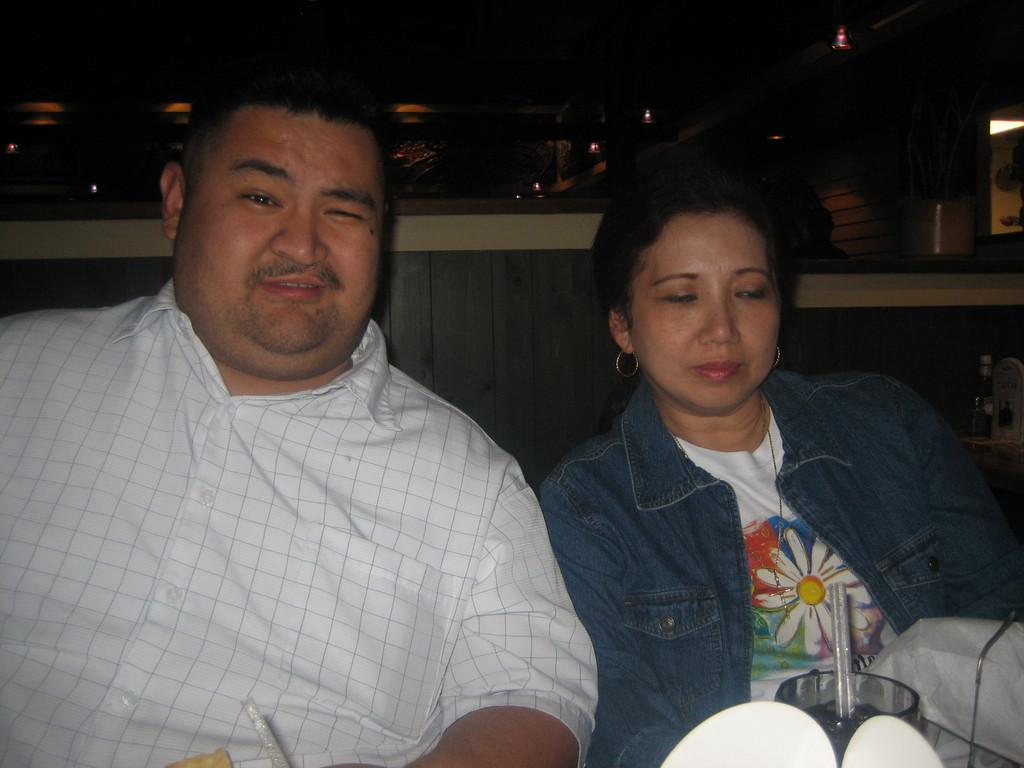Who are the people in the image? There is a man and a woman in the image. What are the man and woman doing in the image? The man and woman are sitting together. What object is in front of them? There is a glass in front of them. What type of pencil can be seen in the image? There is no pencil present in the image. How many steps are visible in the image? There is no reference to steps in the image. 